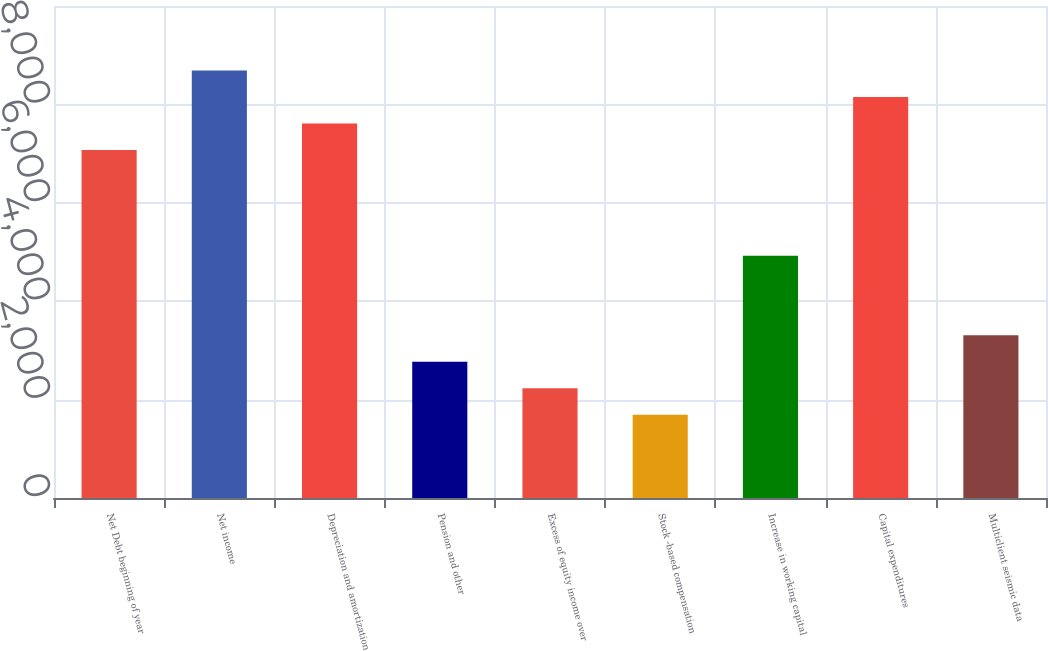Convert chart. <chart><loc_0><loc_0><loc_500><loc_500><bar_chart><fcel>Net Debt beginning of year<fcel>Net income<fcel>Depreciation and amortization<fcel>Pension and other<fcel>Excess of equity income over<fcel>Stock -based compensation<fcel>Increase in working capital<fcel>Capital expenditures<fcel>Multiclient seismic data<nl><fcel>7075.2<fcel>8690.4<fcel>7613.6<fcel>2768<fcel>2229.6<fcel>1691.2<fcel>4921.6<fcel>8152<fcel>3306.4<nl></chart> 